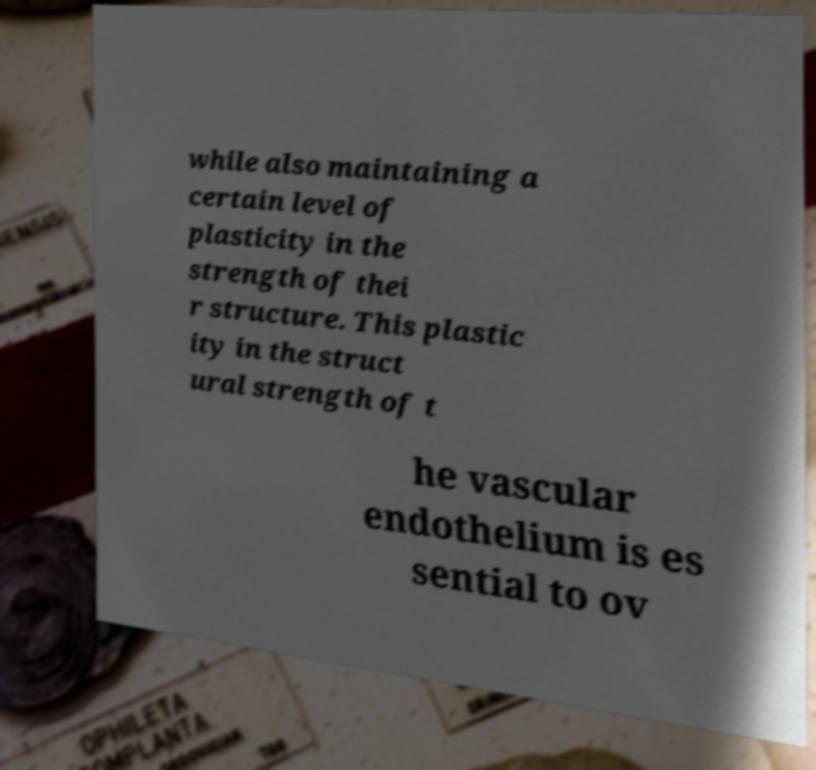Can you accurately transcribe the text from the provided image for me? while also maintaining a certain level of plasticity in the strength of thei r structure. This plastic ity in the struct ural strength of t he vascular endothelium is es sential to ov 